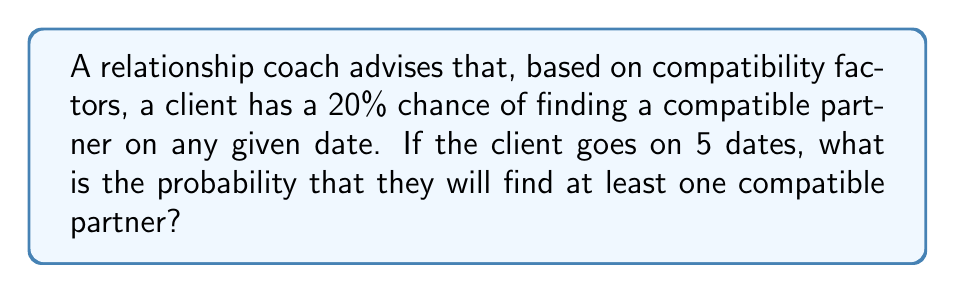Can you solve this math problem? Let's approach this step-by-step:

1) First, let's define our events:
   $p$ = probability of finding a compatible partner on a single date = 0.20
   $q$ = probability of not finding a compatible partner on a single date = 1 - p = 0.80

2) We want to find the probability of finding at least one compatible partner in 5 dates. It's easier to calculate the probability of the complement event: not finding any compatible partners in 5 dates.

3) The probability of not finding a compatible partner in 5 dates is:
   $q^5 = 0.80^5 = 0.32768$

4) Therefore, the probability of finding at least one compatible partner is:
   $1 - q^5 = 1 - 0.32768 = 0.67232$

5) We can also express this using the binomial probability formula:

   $$P(\text{at least one}) = 1 - P(\text{none}) = 1 - \binom{5}{0}p^0q^5 = 1 - (1)(1)(0.80^5) = 0.67232$$

6) Converting to a percentage: $0.67232 \times 100\% = 67.232\%$
Answer: 67.232% 